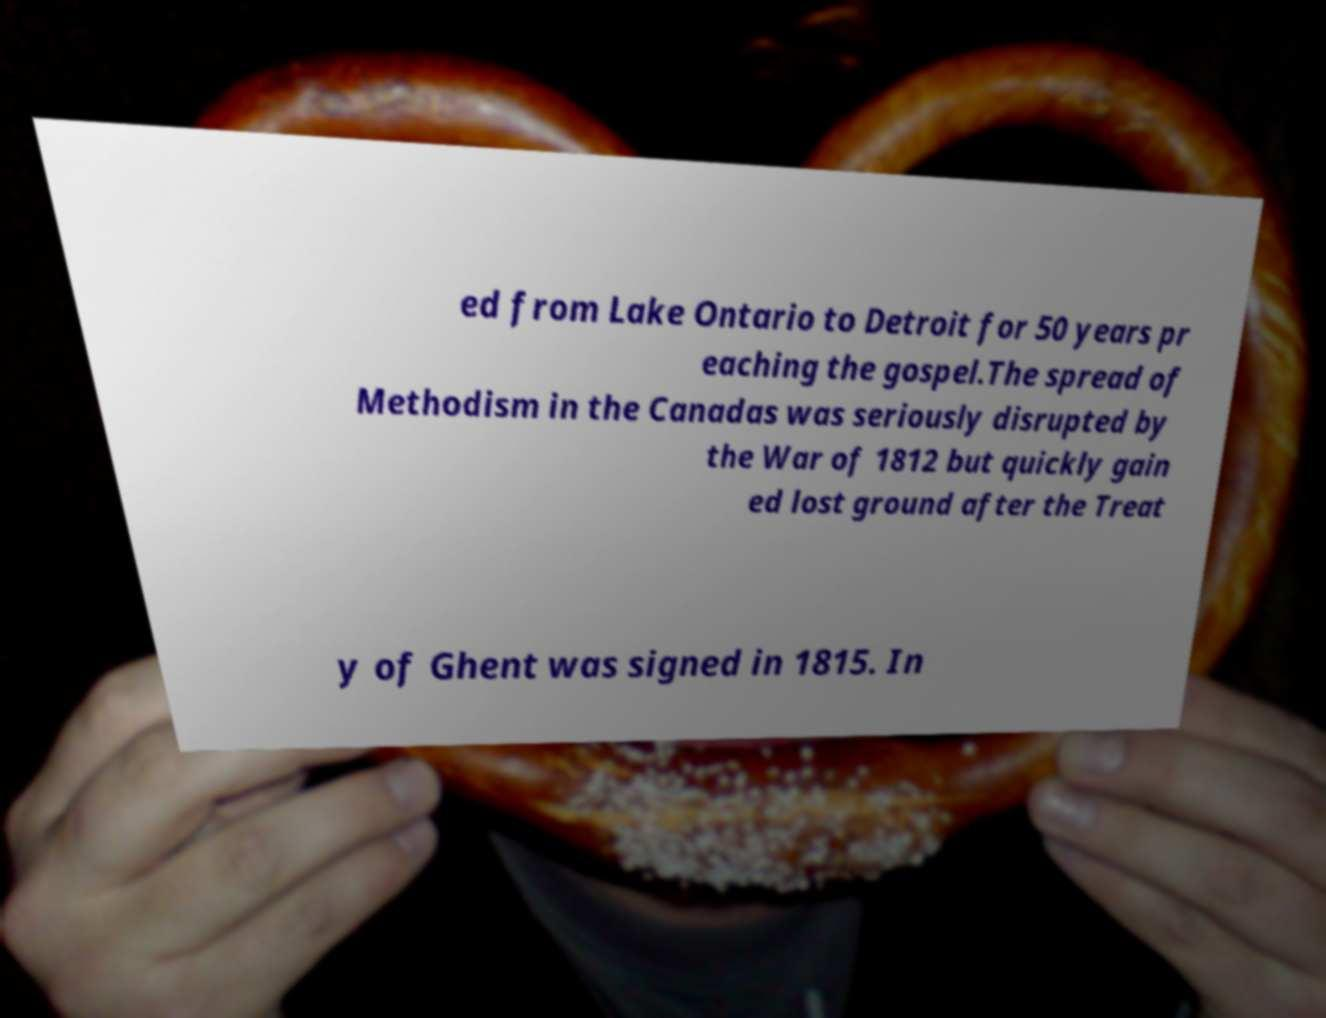There's text embedded in this image that I need extracted. Can you transcribe it verbatim? ed from Lake Ontario to Detroit for 50 years pr eaching the gospel.The spread of Methodism in the Canadas was seriously disrupted by the War of 1812 but quickly gain ed lost ground after the Treat y of Ghent was signed in 1815. In 